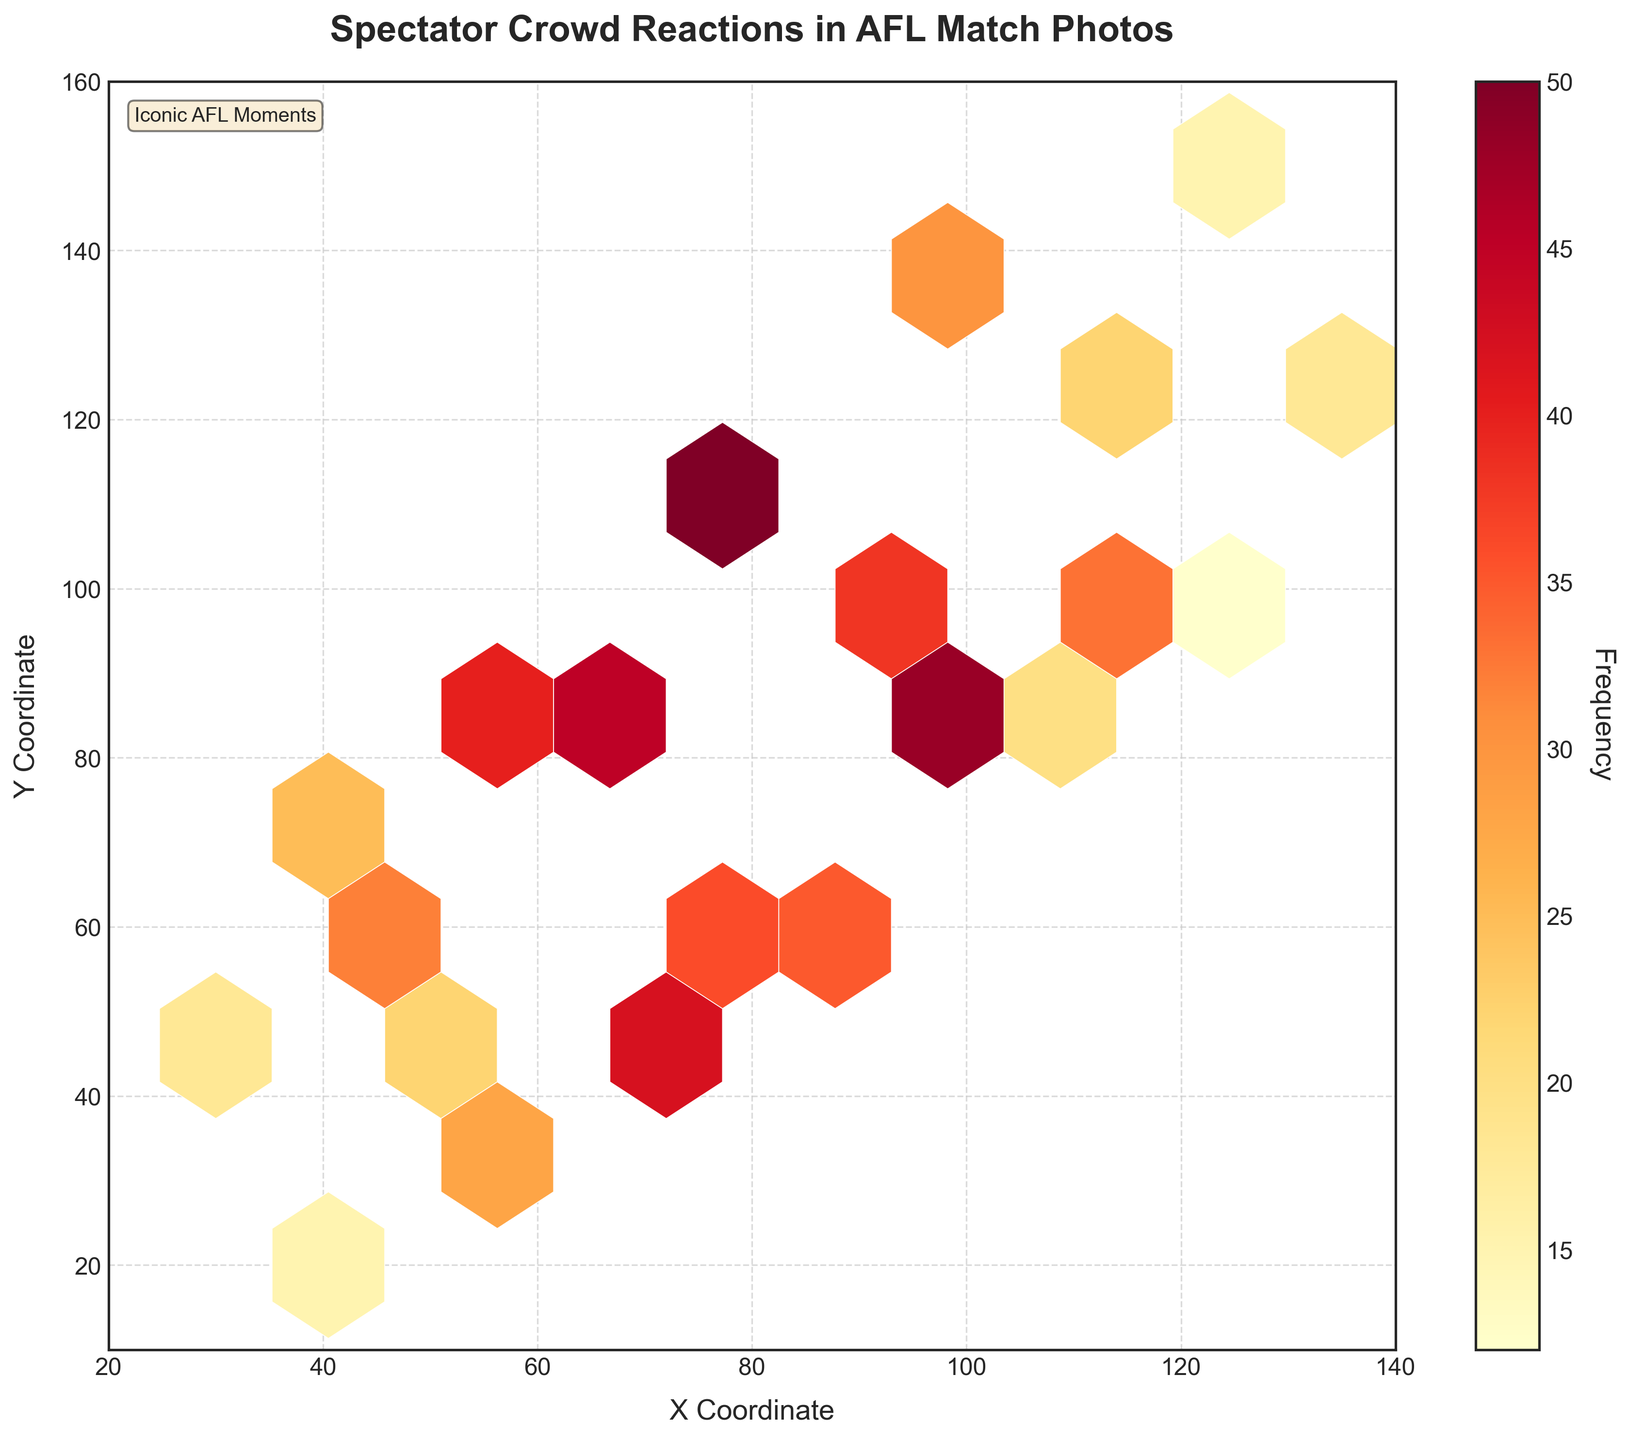What's the title of the plot? The title of the plot is located at the top center of the figure and is in bold.
Answer: Spectator Crowd Reactions in AFL Match Photos What do the X and Y axes represent? The X and Y axes are labeled, which provides information about their representation. The X axis represents the "X Coordinate" and the Y axis represents the "Y Coordinate".
Answer: X Coordinate, Y Coordinate What is the color scale representing? The color scale is represented by the color bar, indicating that the hexbin color from yellow to red shows the "Frequency" of spectator reactions.
Answer: Frequency Which area of the plot has the highest frequency of spectator reactions? The densest, darkest red hexagon indicates the highest frequency of reactions, located near the coordinates around (80, 110).
Answer: Around (80, 110) How does the frequency of reactions change from the bottom left corner to the top right corner? Observing the color shift from yellow to red shows a gradient, indicating increasing frequency. The density and color intensity increase as we move from the lower-left to the upper-right.
Answer: Increases Identify the coordinates with the lowest frequencies. The lightest color (yellow) indicates the lowest frequency. These low-density hexagons are located near the coordinates (45, 20) and (120, 150).
Answer: Around (45, 20) and (120, 150) Between coordinates (60, 35) and (120, 95), which one has a higher frequency of reactions, and how do you determine that? Compare the color intensities at both coordinates. The hexagon at (60, 35) is darker than the one at (120, 95), indicating a higher frequency.
Answer: (60, 35) What's the average frequency of reactions for coordinates (60, 90) and (75, 50)? Find the frequencies for both coordinates, sum them up and divide by the number of coordinates: (40 + 42) / 2 = 41.
Answer: 41 How many distinct hexagons can you count within the grid? Count all the visible hexagons within the plot boundaries to find the total number.
Answer: 22 If the value at the coordinate (95, 85) is 48, what would be the difference between the highest frequency and this value? Find the highest frequency first, which is 50 at (80, 110), then subtract the value at (95, 85): 50 - 48 = 2.
Answer: 2 